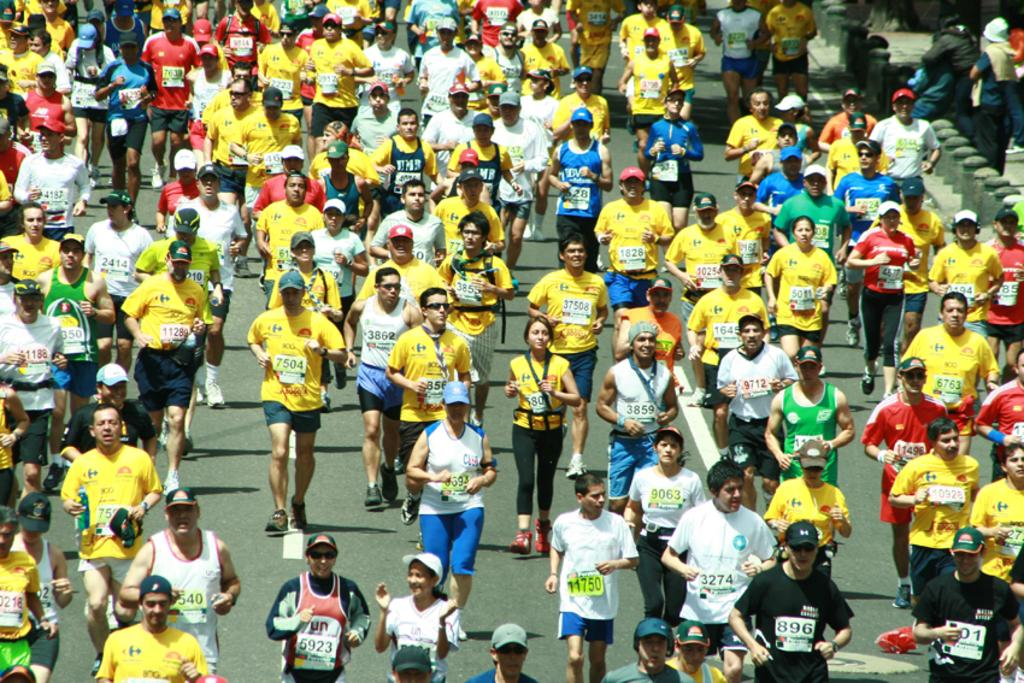How many individuals are present in the image? There are many people in the image. What are the people in the image doing? The people are walking on the road. What type of quill is being used by the people walking on the road in the image? There is no quill present in the image; the people are simply walking on the road. How many balls can be seen being juggled by the people in the image? There are no balls or juggling activities depicted in the image; the people are walking on the road. 